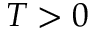<formula> <loc_0><loc_0><loc_500><loc_500>T > 0</formula> 